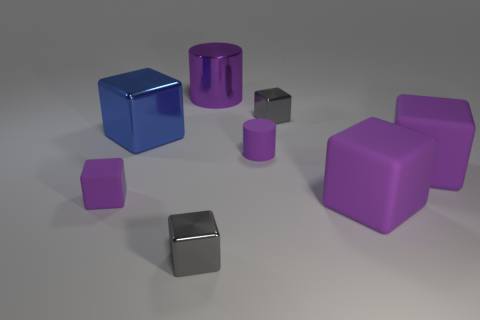Subtract all purple cubes. How many were subtracted if there are1purple cubes left? 2 Subtract all blue cylinders. How many purple cubes are left? 3 Subtract 1 blocks. How many blocks are left? 5 Subtract all large purple blocks. How many blocks are left? 4 Subtract all blue cubes. How many cubes are left? 5 Subtract all blue cubes. Subtract all green balls. How many cubes are left? 5 Add 2 tiny cylinders. How many objects exist? 10 Subtract all cylinders. How many objects are left? 6 Subtract all blocks. Subtract all small matte cylinders. How many objects are left? 1 Add 5 small purple cylinders. How many small purple cylinders are left? 6 